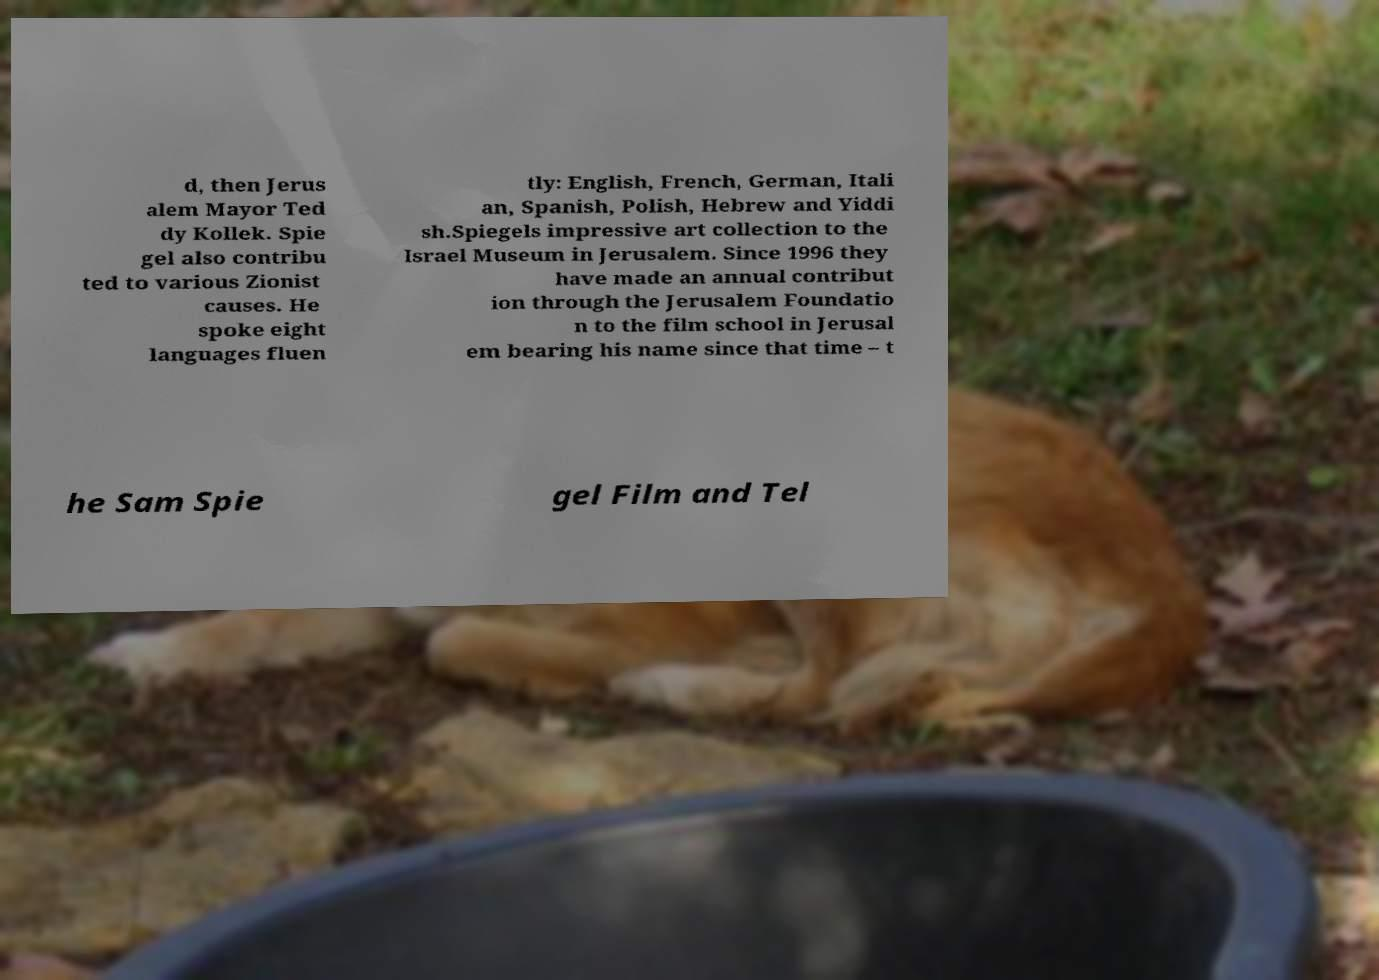Please read and relay the text visible in this image. What does it say? d, then Jerus alem Mayor Ted dy Kollek. Spie gel also contribu ted to various Zionist causes. He spoke eight languages fluen tly: English, French, German, Itali an, Spanish, Polish, Hebrew and Yiddi sh.Spiegels impressive art collection to the Israel Museum in Jerusalem. Since 1996 they have made an annual contribut ion through the Jerusalem Foundatio n to the film school in Jerusal em bearing his name since that time – t he Sam Spie gel Film and Tel 